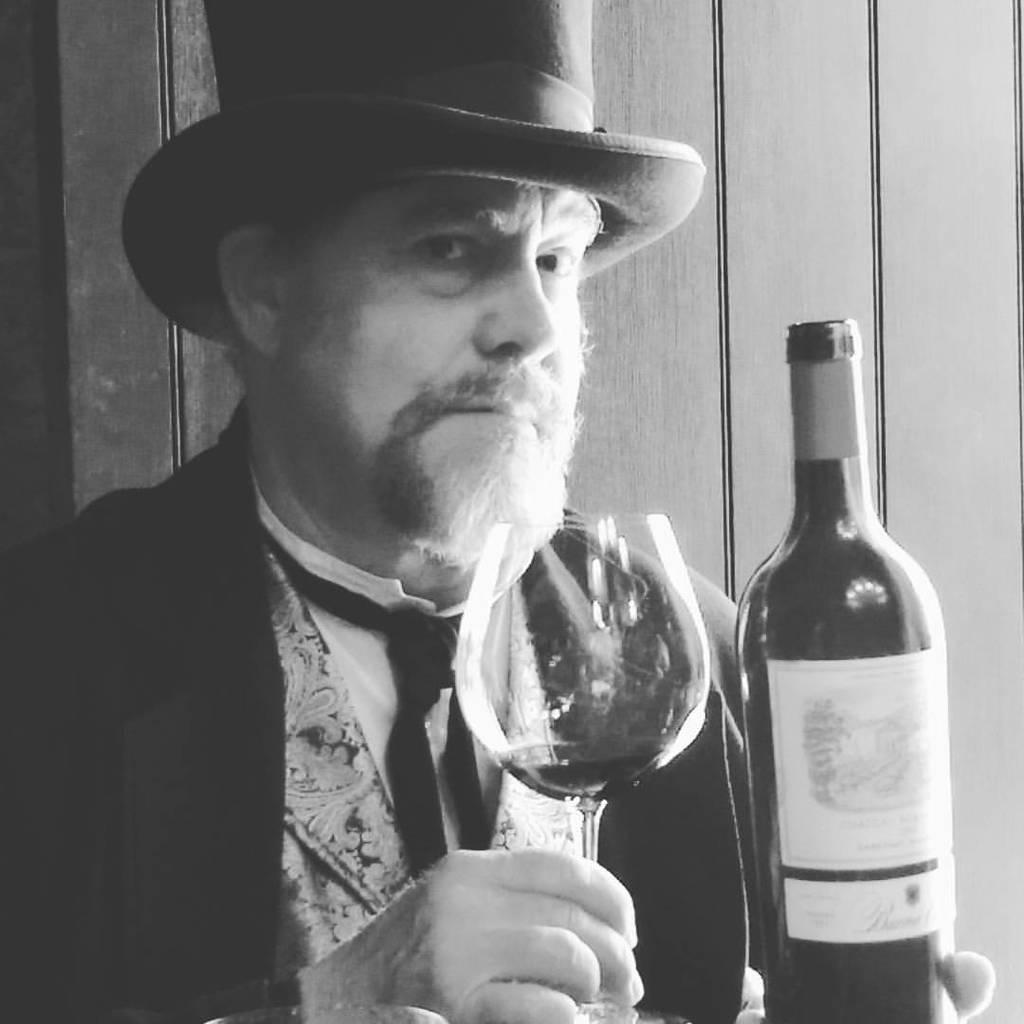Who is present in the image? There is a man in the image. What is the man holding in his hands? The man is holding a wine glass and a wine bottle. What is the man wearing on his upper body? The man is wearing a black coat. What type of headwear is the man wearing? The man is wearing a hat. What type of string is the man using to hold the wine glass and bottle together? There is no string present in the image; the man is holding the wine glass and bottle separately. 